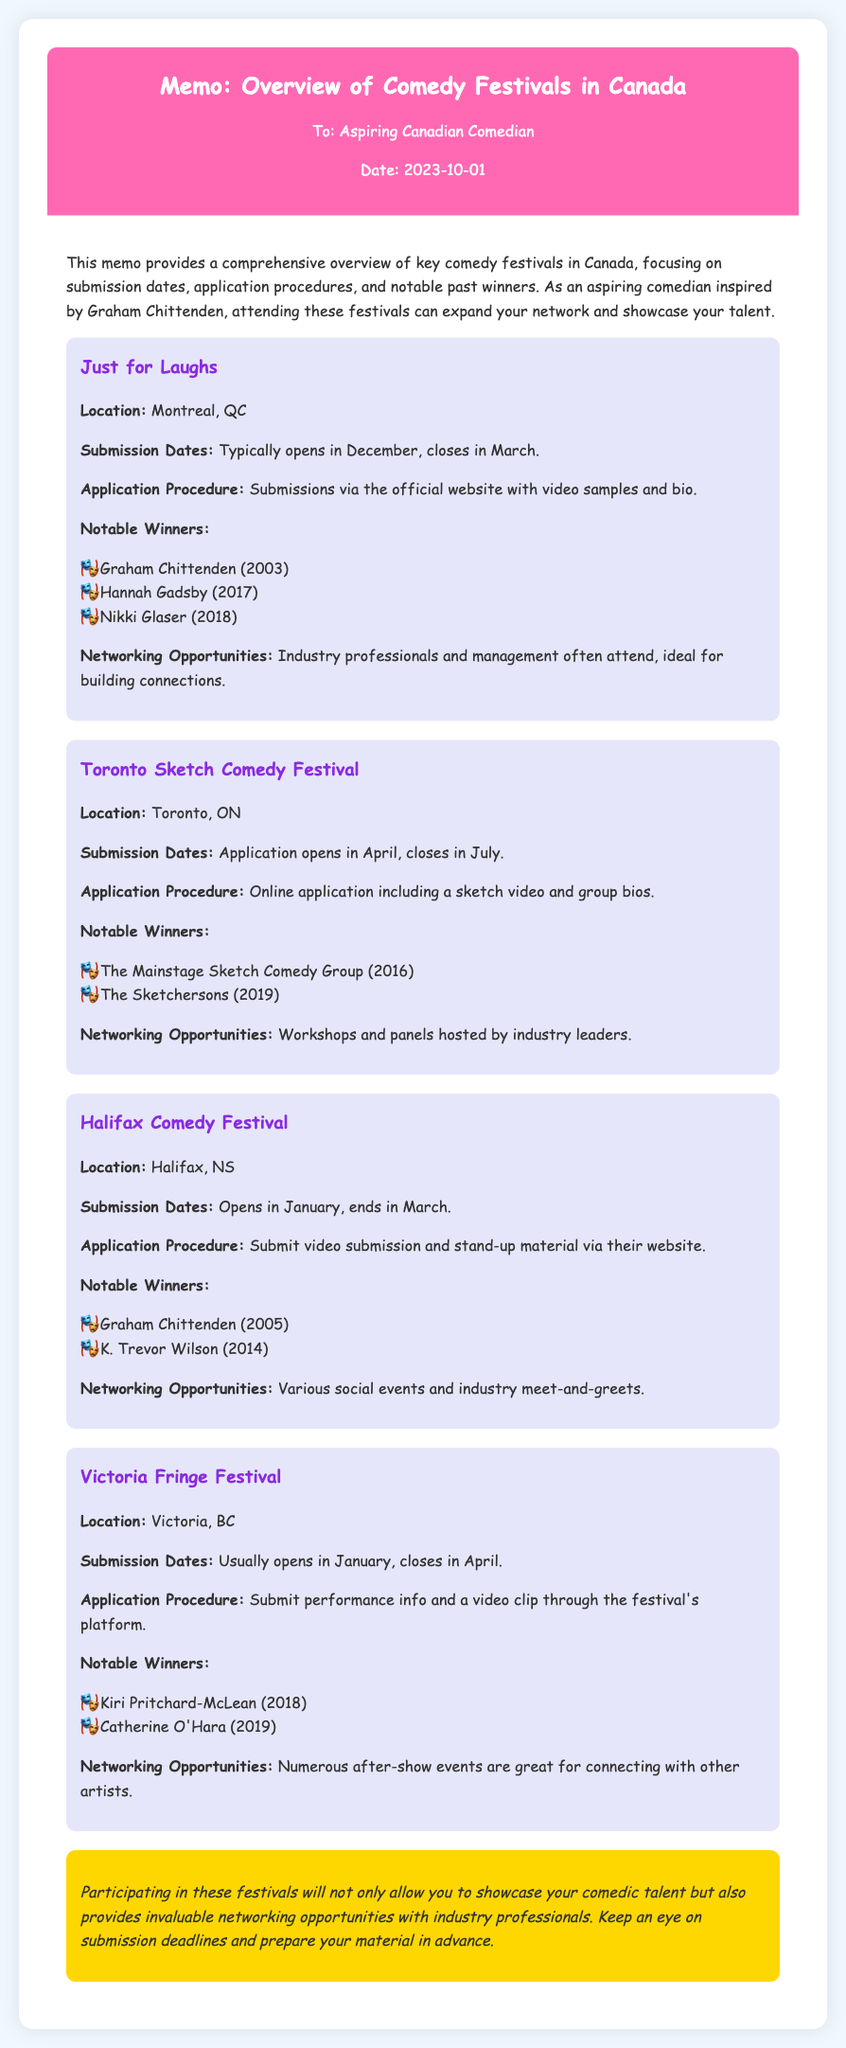what is the location of Just for Laughs? The location of Just for Laughs is specified in the document as Montreal, QC.
Answer: Montreal, QC what are the submission dates for the Halifax Comedy Festival? The document states the submission dates for the Halifax Comedy Festival as opening in January and ending in March.
Answer: January to March who won the Toronto Sketch Comedy Festival in 2019? The document mentions the winners of the Toronto Sketch Comedy Festival, naming The Sketchersons as the 2019 winner.
Answer: The Sketchersons what type of application procedure is required for the Victoria Fringe Festival? The application procedure for the Victoria Fringe Festival includes submitting performance info and a video clip through the festival's platform.
Answer: Performance info and a video clip how many notable winners are listed for the Just for Laughs festival? The document lists three notable winners for Just for Laughs, including Graham Chittenden, Hannah Gadsby, and Nikki Glaser.
Answer: Three what networking opportunities are mentioned for the Halifax Comedy Festival? The networking opportunities highlighted for the Halifax Comedy Festival include various social events and industry meet-and-greets.
Answer: Social events and industry meet-and-greets when does the submission for the Toronto Sketch Comedy Festival typically close? According to the document, the submission for the Toronto Sketch Comedy Festival typically closes in July.
Answer: July which festival featured Graham Chittenden as a winner in 2003? The document points out that Graham Chittenden won Just for Laughs in 2003.
Answer: Just for Laughs 